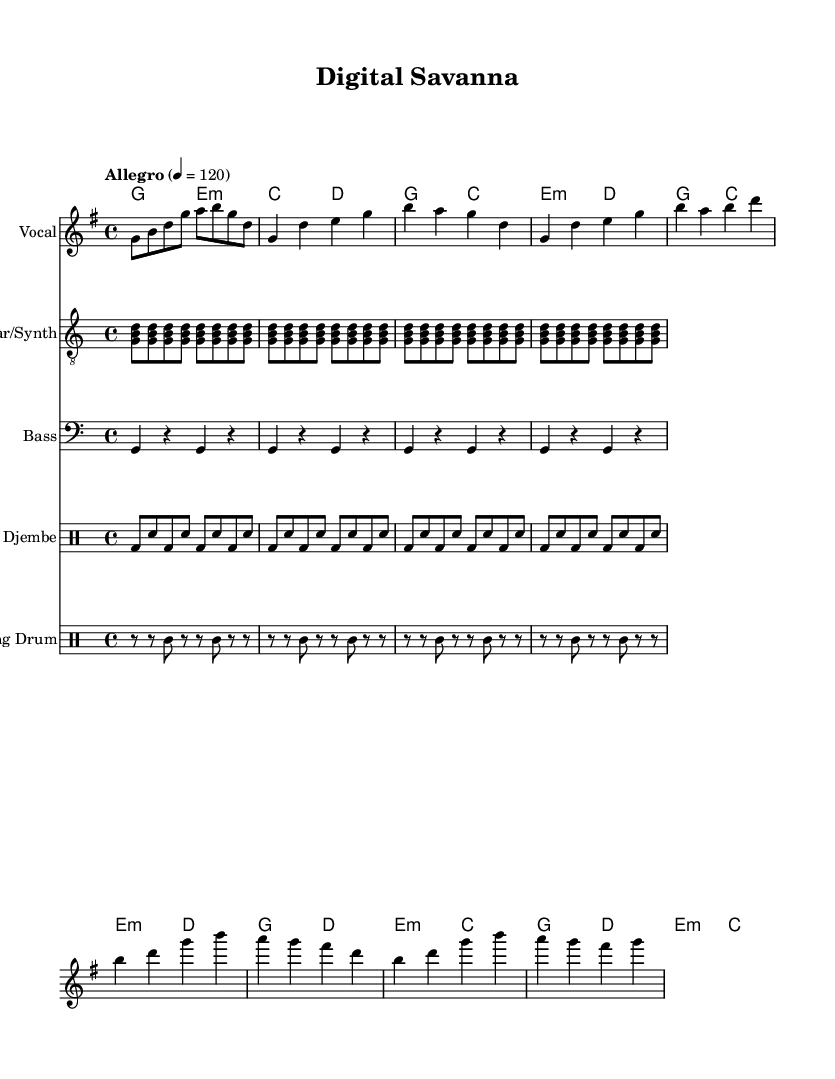What is the key signature of this music? The key signature is G major, which has one sharp (F#).
Answer: G major What is the time signature of this piece? The time signature is 4/4, indicating four beats per measure.
Answer: 4/4 What is the tempo marking for this piece? The tempo marking is "Allegro", with a speed indication of 120 beats per minute.
Answer: Allegro What types of drums are used in this composition? The composition features a Djembe and a Talking Drum, which are both traditional African percussion instruments.
Answer: Djembe and Talking Drum How many measures are in the Chorus section? The Chorus consists of 4 measures, as indicated by the repeated patterns shown in the score.
Answer: 4 What chords are played during the Verse section? The chords in the Verse are G, C, E minor, and D, played in that sequence as per the chord modes.
Answer: G, C, E minor, D What fusion genres are celebrated in the piece? The piece is an upbeat African fusion celebrating technological innovation, reflected in its instrumentation and rhythmic style.
Answer: Upbeat African fusion 